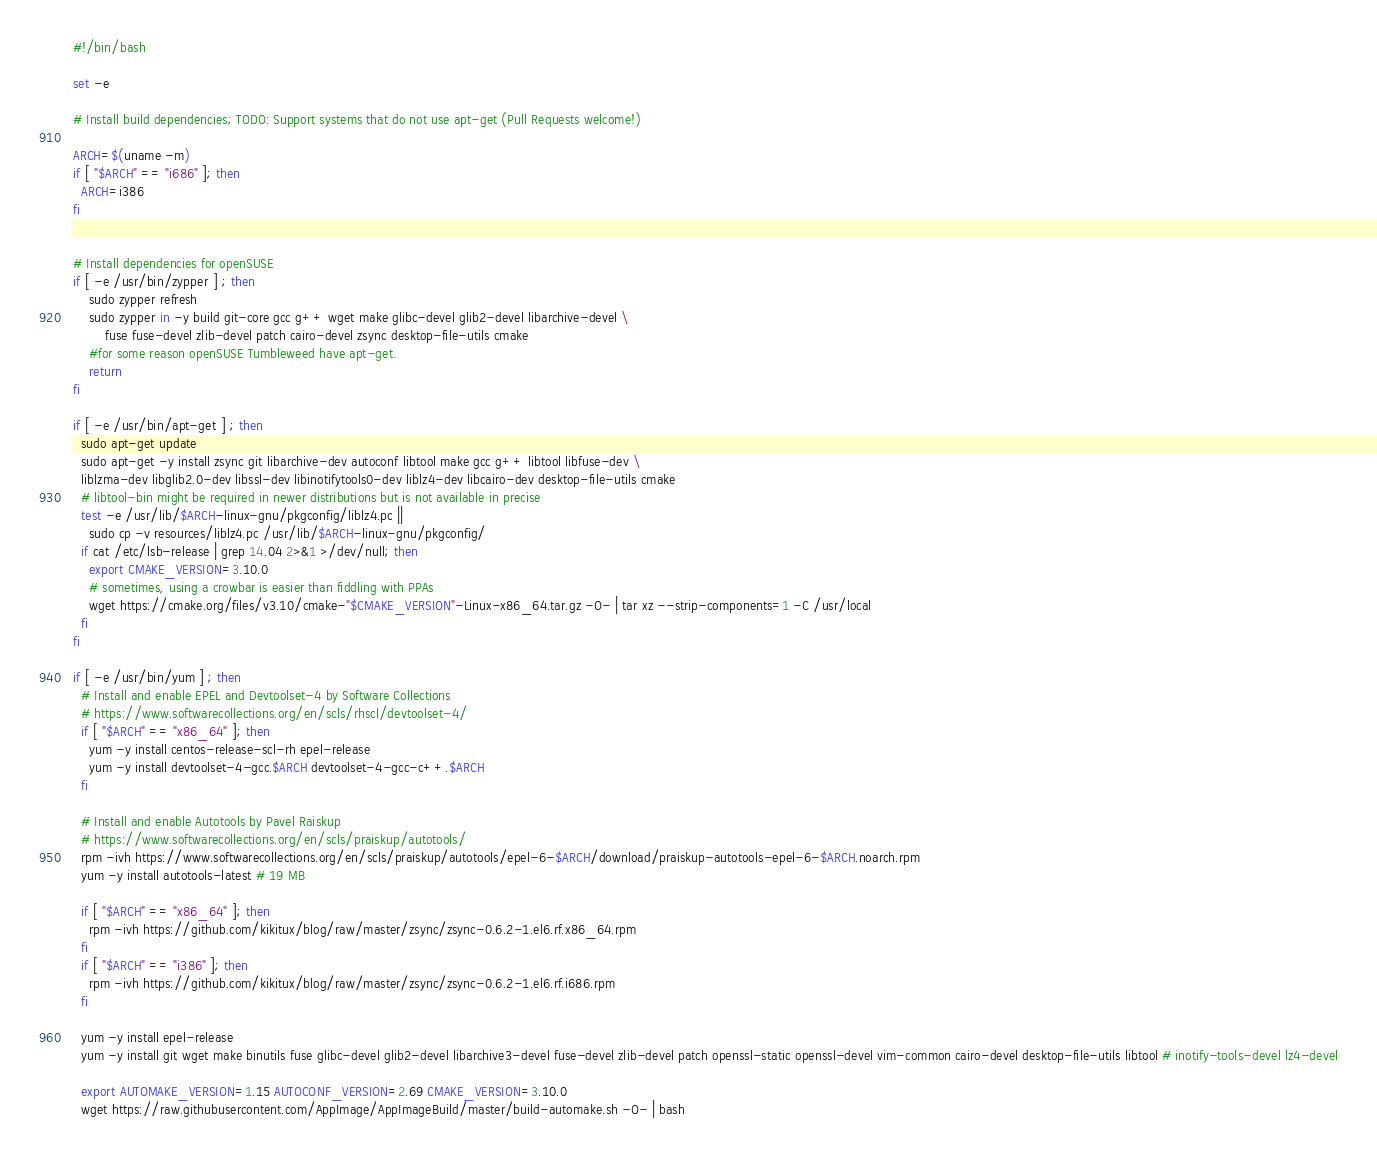<code> <loc_0><loc_0><loc_500><loc_500><_Bash_>#!/bin/bash

set -e

# Install build dependencies; TODO: Support systems that do not use apt-get (Pull Requests welcome!)

ARCH=$(uname -m)
if [ "$ARCH" == "i686" ]; then
  ARCH=i386
fi


# Install dependencies for openSUSE
if [ -e /usr/bin/zypper ] ; then
    sudo zypper refresh
    sudo zypper in -y build git-core gcc g++ wget make glibc-devel glib2-devel libarchive-devel \
        fuse fuse-devel zlib-devel patch cairo-devel zsync desktop-file-utils cmake
    #for some reason openSUSE Tumbleweed have apt-get.
    return
fi

if [ -e /usr/bin/apt-get ] ; then
  sudo apt-get update
  sudo apt-get -y install zsync git libarchive-dev autoconf libtool make gcc g++ libtool libfuse-dev \
  liblzma-dev libglib2.0-dev libssl-dev libinotifytools0-dev liblz4-dev libcairo-dev desktop-file-utils cmake
  # libtool-bin might be required in newer distributions but is not available in precise
  test -e /usr/lib/$ARCH-linux-gnu/pkgconfig/liblz4.pc ||
    sudo cp -v resources/liblz4.pc /usr/lib/$ARCH-linux-gnu/pkgconfig/
  if cat /etc/lsb-release | grep 14.04 2>&1 >/dev/null; then
    export CMAKE_VERSION=3.10.0
    # sometimes, using a crowbar is easier than fiddling with PPAs
    wget https://cmake.org/files/v3.10/cmake-"$CMAKE_VERSION"-Linux-x86_64.tar.gz -O- | tar xz --strip-components=1 -C /usr/local
  fi
fi

if [ -e /usr/bin/yum ] ; then
  # Install and enable EPEL and Devtoolset-4 by Software Collections
  # https://www.softwarecollections.org/en/scls/rhscl/devtoolset-4/
  if [ "$ARCH" == "x86_64" ]; then
    yum -y install centos-release-scl-rh epel-release
    yum -y install devtoolset-4-gcc.$ARCH devtoolset-4-gcc-c++.$ARCH
  fi

  # Install and enable Autotools by Pavel Raiskup
  # https://www.softwarecollections.org/en/scls/praiskup/autotools/
  rpm -ivh https://www.softwarecollections.org/en/scls/praiskup/autotools/epel-6-$ARCH/download/praiskup-autotools-epel-6-$ARCH.noarch.rpm
  yum -y install autotools-latest # 19 MB

  if [ "$ARCH" == "x86_64" ]; then
    rpm -ivh https://github.com/kikitux/blog/raw/master/zsync/zsync-0.6.2-1.el6.rf.x86_64.rpm
  fi
  if [ "$ARCH" == "i386" ]; then
    rpm -ivh https://github.com/kikitux/blog/raw/master/zsync/zsync-0.6.2-1.el6.rf.i686.rpm
  fi

  yum -y install epel-release
  yum -y install git wget make binutils fuse glibc-devel glib2-devel libarchive3-devel fuse-devel zlib-devel patch openssl-static openssl-devel vim-common cairo-devel desktop-file-utils libtool # inotify-tools-devel lz4-devel

  export AUTOMAKE_VERSION=1.15 AUTOCONF_VERSION=2.69 CMAKE_VERSION=3.10.0
  wget https://raw.githubusercontent.com/AppImage/AppImageBuild/master/build-automake.sh -O- | bash</code> 